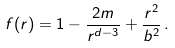<formula> <loc_0><loc_0><loc_500><loc_500>f ( r ) = 1 - \frac { 2 m } { r ^ { d - 3 } } + \frac { r ^ { 2 } } { b ^ { 2 } } \, .</formula> 